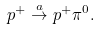Convert formula to latex. <formula><loc_0><loc_0><loc_500><loc_500>p ^ { + } \stackrel { a } { \to } p ^ { + } \pi ^ { 0 } .</formula> 